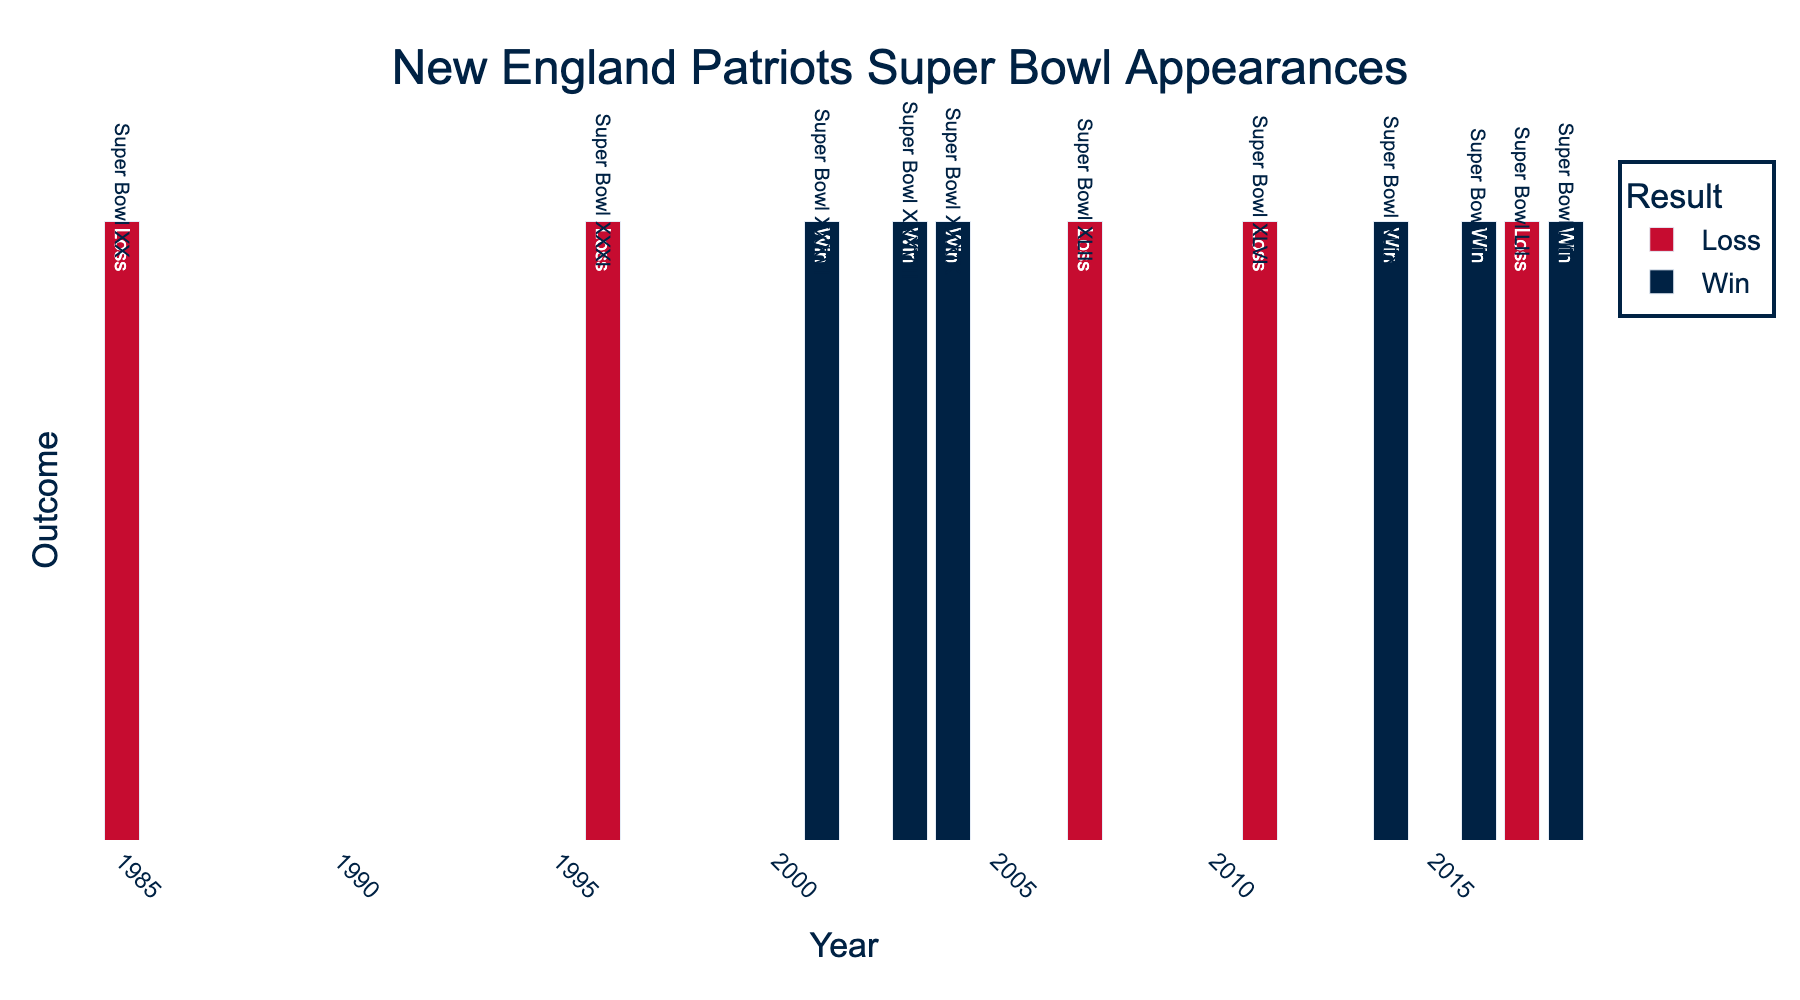Which Super Bowl appearance occurred in 2007, and what was the outcome? Look at the bar for the year 2007. The label indicates Super Bowl XLII, and it is marked with 'Loss' in red.
Answer: Super Bowl XLII, Loss How many Super Bowl wins did the New England Patriots have between 2001 and 2018? Sum the 'Win' counts from the years within that range (2001, 2003, 2004, 2014, 2016, 2018). Each win is marked by a blue bar and totals 6.
Answer: 6 Compare the number of Super Bowl appearances in the 1990s and 2010s. How many more appearances were there in one decade than the other? The 1990s (1996) have 1 appearance, while the 2010s (2011, 2014, 2016, 2017, 2018) have 5 appearances. Hence, there were 4 more appearances in the 2010s.
Answer: 4 more in the 2010s In which years did the New England Patriots lose a Super Bowl? Observing the red bars, the years with losses are 1985, 1996, 2007, 2011, and 2017.
Answer: 1985, 1996, 2007, 2011, 2017 Which year marked the first Super Bowl win for the New England Patriots, and which Super Bowl was it? The first blue bar indicating a 'Win' is in 2001, labeled as Super Bowl XXXVI.
Answer: 2001, Super Bowl XXXVI How many years had both a Super Bowl win and a loss for the New England Patriots? Check for years that have both blue (Win) and red (Loss) bars at non-zero heights. Since each year has only one bar, there are no such years.
Answer: 0 Calculate the total number of Super Bowl appearances by the New England Patriots from 1985 to 2018. Count all bars (both blue and red) within the given range. The total sum is 11.
Answer: 11 Which decade featured the most frequent Super Bowl wins for the New England Patriots? Count blue bars in each decade: 2000s (3), 2010s (3). Both decades have 3 wins, making it a tie.
Answer: 2000s and 2010s (tie) How many consecutive years did the New England Patriots appear in the Super Bowl from 2016 to 2018? Check the sequence of bars from 2016 to 2018 and count the appearances. They appeared in 2016, 2017, and 2018, making it 3 consecutive years.
Answer: 3 